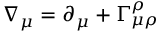Convert formula to latex. <formula><loc_0><loc_0><loc_500><loc_500>\nabla _ { \mu } = \partial _ { \mu } + \Gamma _ { \mu \rho } ^ { \rho }</formula> 